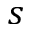Convert formula to latex. <formula><loc_0><loc_0><loc_500><loc_500>s</formula> 